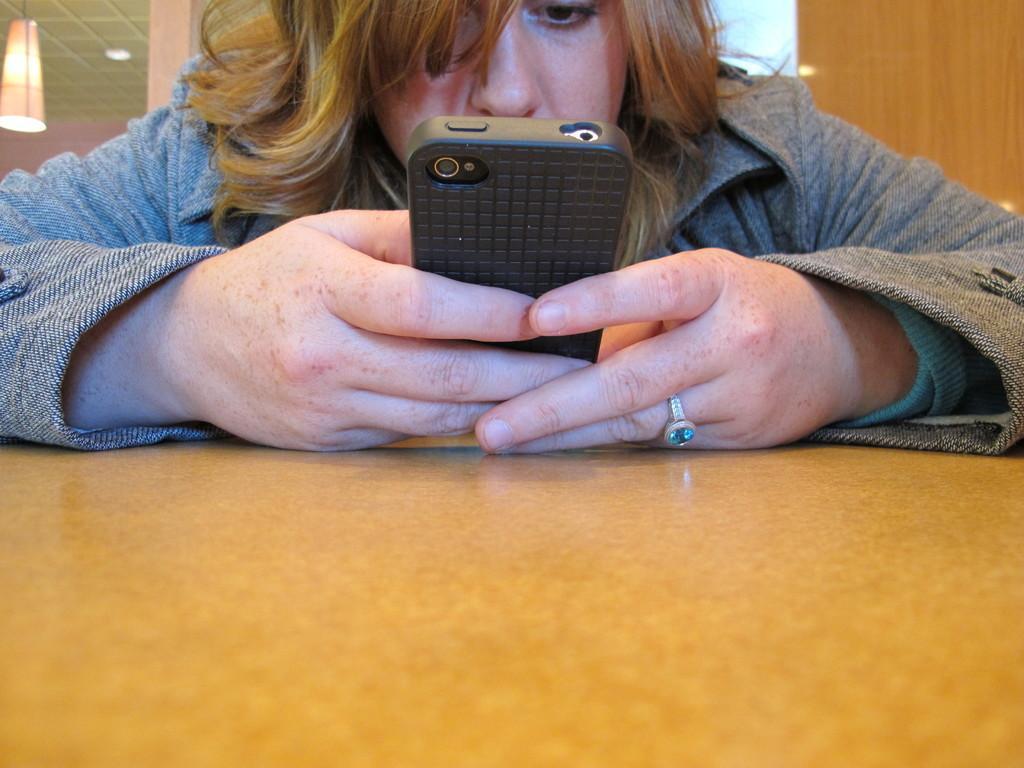Can you describe this image briefly? In this image i can see a woman holding mobile on a table,at the background i can see a wooden wall and a light. 